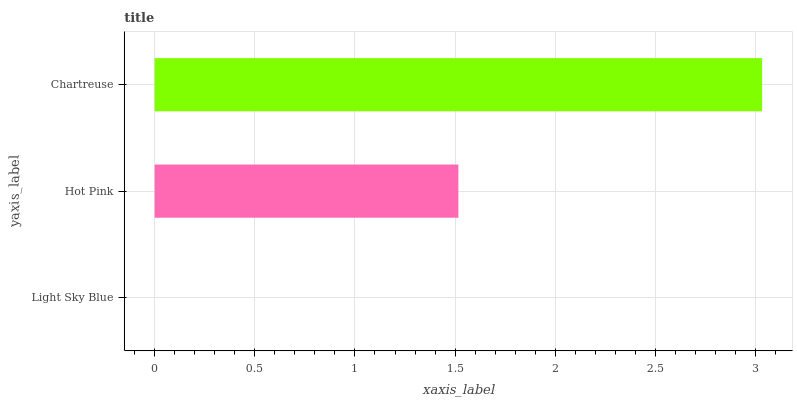Is Light Sky Blue the minimum?
Answer yes or no. Yes. Is Chartreuse the maximum?
Answer yes or no. Yes. Is Hot Pink the minimum?
Answer yes or no. No. Is Hot Pink the maximum?
Answer yes or no. No. Is Hot Pink greater than Light Sky Blue?
Answer yes or no. Yes. Is Light Sky Blue less than Hot Pink?
Answer yes or no. Yes. Is Light Sky Blue greater than Hot Pink?
Answer yes or no. No. Is Hot Pink less than Light Sky Blue?
Answer yes or no. No. Is Hot Pink the high median?
Answer yes or no. Yes. Is Hot Pink the low median?
Answer yes or no. Yes. Is Light Sky Blue the high median?
Answer yes or no. No. Is Chartreuse the low median?
Answer yes or no. No. 